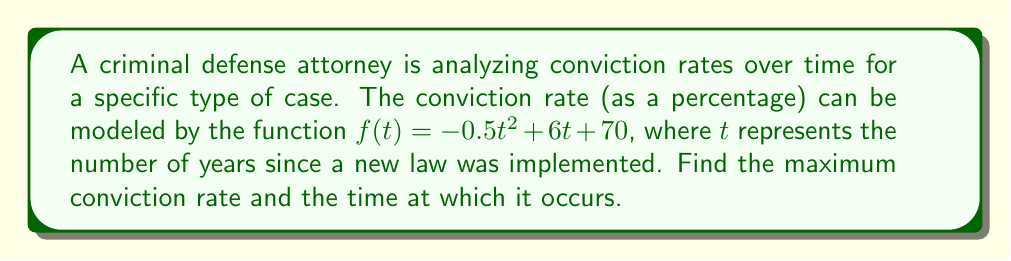Teach me how to tackle this problem. To find the maximum point on this graph, we need to follow these steps:

1) The maximum or minimum of a quadratic function occurs at the vertex of the parabola. For a function in the form $f(t) = at^2 + bt + c$, the t-coordinate of the vertex is given by $t = -\frac{b}{2a}$.

2) In our function $f(t) = -0.5t^2 + 6t + 70$, we have:
   $a = -0.5$
   $b = 6$
   $c = 70$

3) Let's calculate the t-coordinate of the vertex:
   $t = -\frac{b}{2a} = -\frac{6}{2(-0.5)} = -\frac{6}{-1} = 6$

4) To find the maximum conviction rate, we need to plug this t-value back into our original function:

   $f(6) = -0.5(6)^2 + 6(6) + 70$
         $= -0.5(36) + 36 + 70$
         $= -18 + 36 + 70$
         $= 88$

5) Therefore, the maximum conviction rate is 88%, occurring 6 years after the new law was implemented.

This analysis could be crucial for a criminal defense attorney to understand trends in conviction rates and potentially argue for changes in law enforcement practices or legislative reforms.
Answer: Maximum conviction rate: 88% at $t = 6$ years 